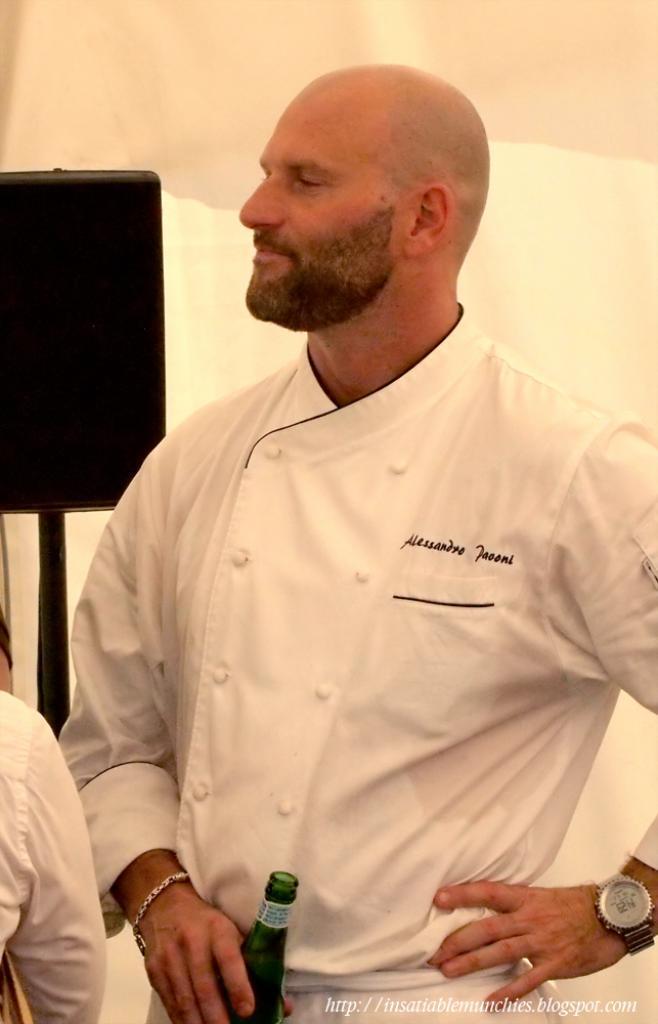What is the name of this person?
Offer a terse response. Unanswerable. 